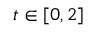Convert formula to latex. <formula><loc_0><loc_0><loc_500><loc_500>t \in [ 0 , 2 ]</formula> 